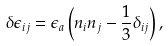Convert formula to latex. <formula><loc_0><loc_0><loc_500><loc_500>\delta \epsilon _ { i j } = \epsilon _ { a } \left ( n _ { i } n _ { j } - \frac { 1 } { 3 } \delta _ { i j } \right ) ,</formula> 